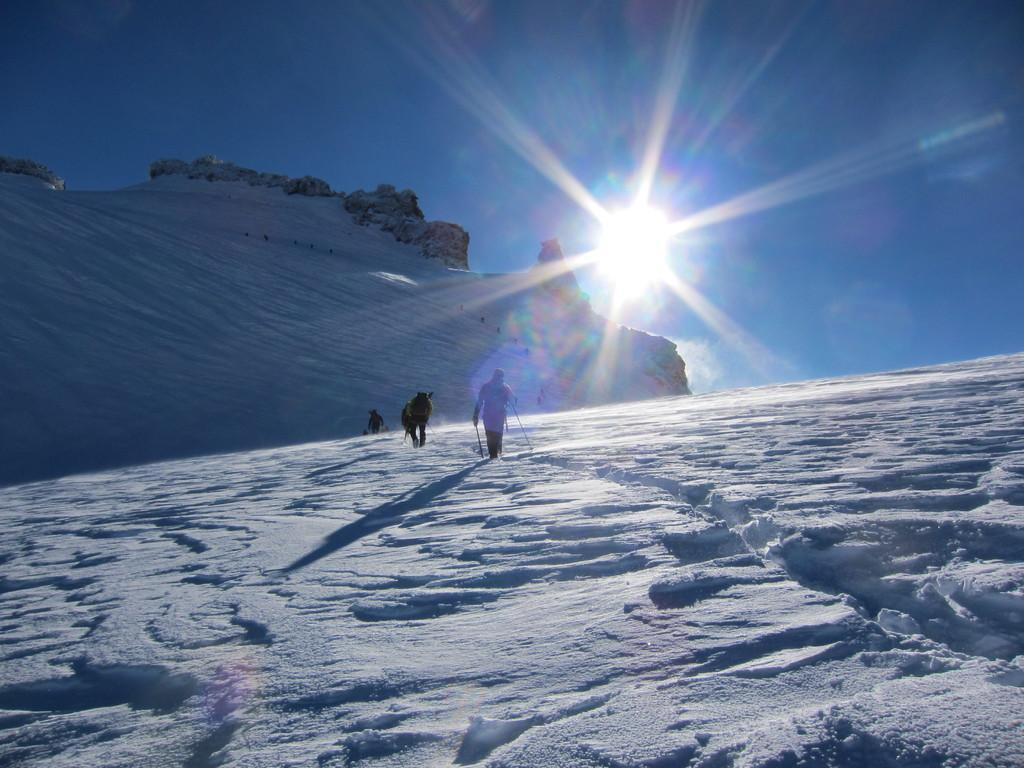What is happening in the image? There are people in the image, and they are walking. What are the people holding in the image? The people are holding sticks. What can be seen in the background of the image? There are hills in the background of the image. What is visible at the top of the image? The sun and sky are visible at the top of the image. What type of lettuce is being used as a waste disposal method in the image? There is no lettuce or waste disposal method present in the image. Can you tell me the name of the father in the image? There is no mention of a father or any specific individuals in the image. 